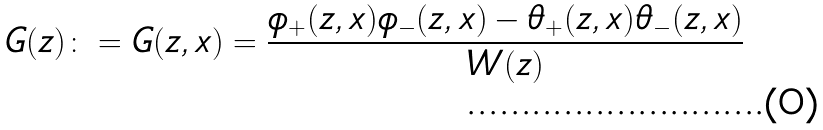<formula> <loc_0><loc_0><loc_500><loc_500>G ( z ) \colon = G ( z , x ) = \frac { \phi _ { + } ( z , x ) \phi _ { - } ( z , x ) - \theta _ { + } ( z , x ) \theta _ { - } ( z , x ) } { W ( z ) }</formula> 